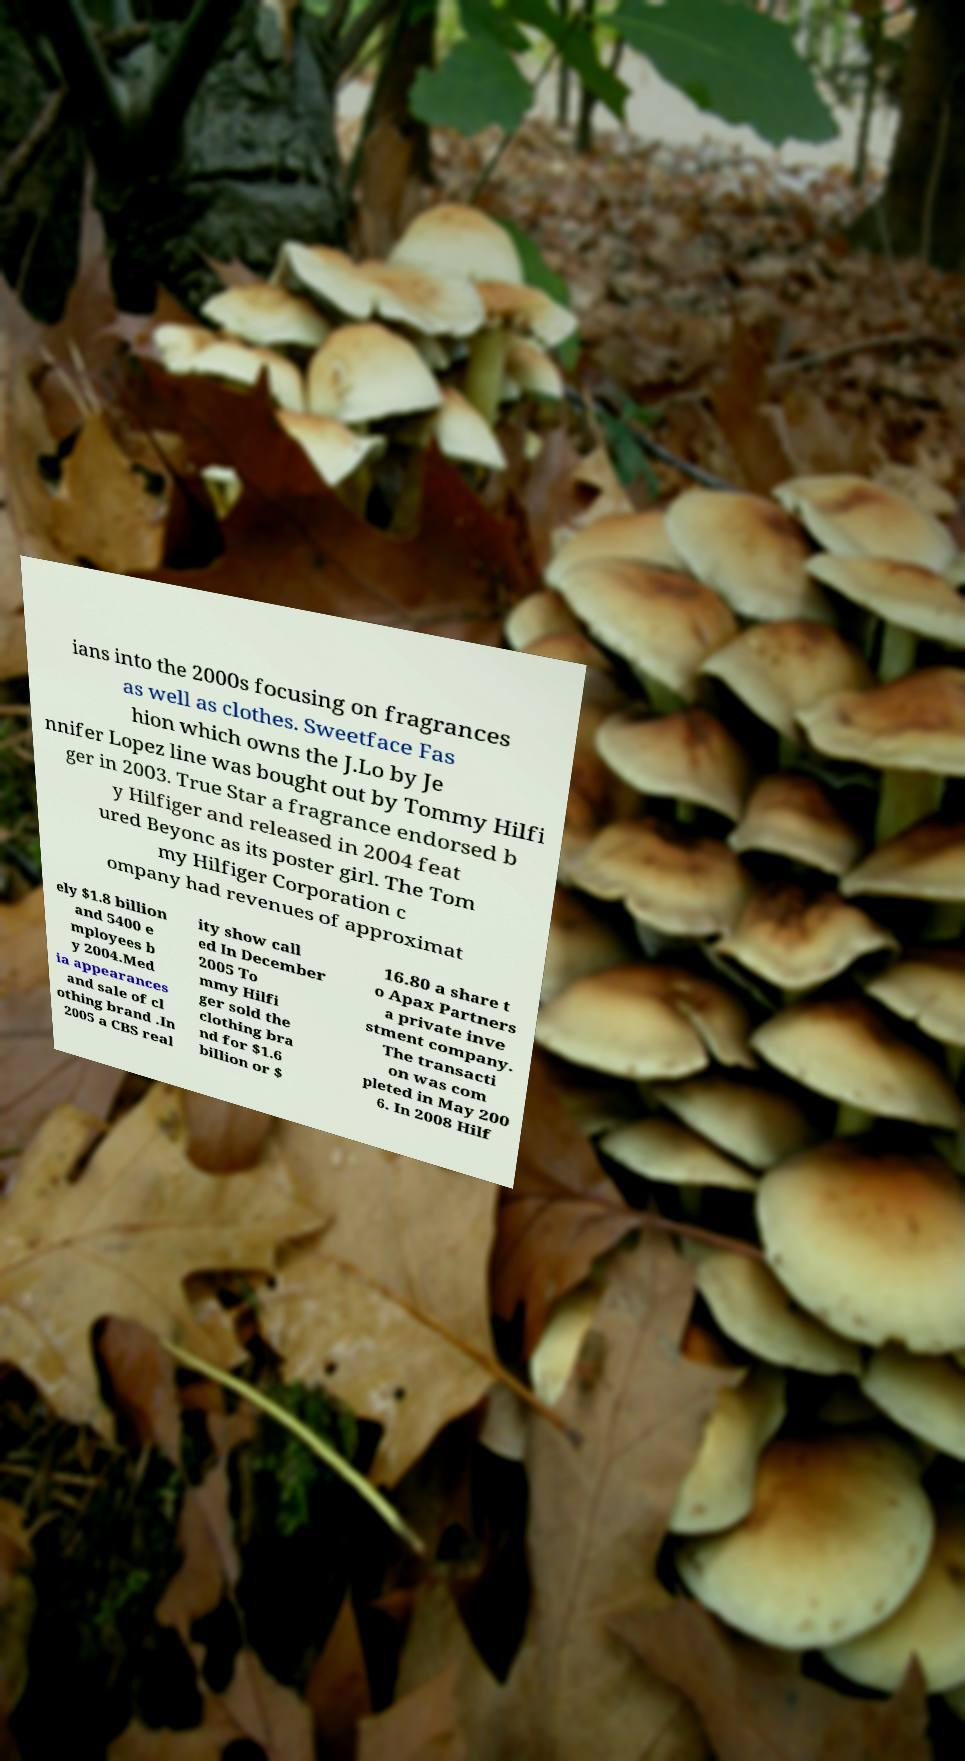What messages or text are displayed in this image? I need them in a readable, typed format. ians into the 2000s focusing on fragrances as well as clothes. Sweetface Fas hion which owns the J.Lo by Je nnifer Lopez line was bought out by Tommy Hilfi ger in 2003. True Star a fragrance endorsed b y Hilfiger and released in 2004 feat ured Beyonc as its poster girl. The Tom my Hilfiger Corporation c ompany had revenues of approximat ely $1.8 billion and 5400 e mployees b y 2004.Med ia appearances and sale of cl othing brand .In 2005 a CBS real ity show call ed In December 2005 To mmy Hilfi ger sold the clothing bra nd for $1.6 billion or $ 16.80 a share t o Apax Partners a private inve stment company. The transacti on was com pleted in May 200 6. In 2008 Hilf 